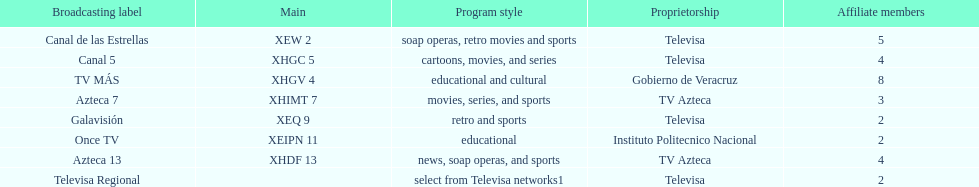Name each of tv azteca's network names. Azteca 7, Azteca 13. Would you be able to parse every entry in this table? {'header': ['Broadcasting label', 'Main', 'Program style', 'Proprietorship', 'Affiliate members'], 'rows': [['Canal de las Estrellas', 'XEW 2', 'soap operas, retro movies and sports', 'Televisa', '5'], ['Canal 5', 'XHGC 5', 'cartoons, movies, and series', 'Televisa', '4'], ['TV MÁS', 'XHGV 4', 'educational and cultural', 'Gobierno de Veracruz', '8'], ['Azteca 7', 'XHIMT 7', 'movies, series, and sports', 'TV Azteca', '3'], ['Galavisión', 'XEQ 9', 'retro and sports', 'Televisa', '2'], ['Once TV', 'XEIPN 11', 'educational', 'Instituto Politecnico Nacional', '2'], ['Azteca 13', 'XHDF 13', 'news, soap operas, and sports', 'TV Azteca', '4'], ['Televisa Regional', '', 'select from Televisa networks1', 'Televisa', '2']]} 